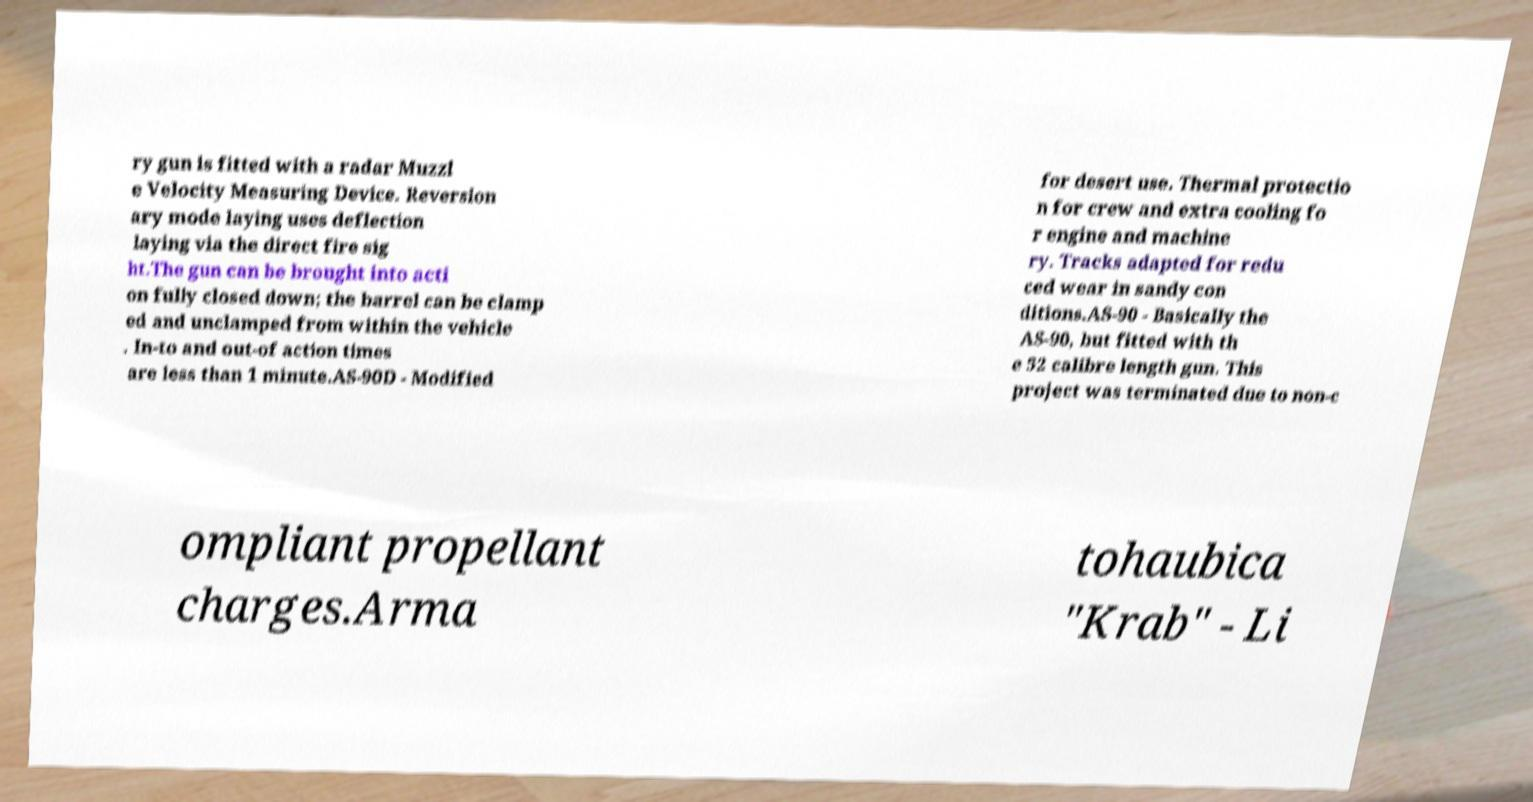Please read and relay the text visible in this image. What does it say? ry gun is fitted with a radar Muzzl e Velocity Measuring Device. Reversion ary mode laying uses deflection laying via the direct fire sig ht.The gun can be brought into acti on fully closed down; the barrel can be clamp ed and unclamped from within the vehicle . In-to and out-of action times are less than 1 minute.AS-90D - Modified for desert use. Thermal protectio n for crew and extra cooling fo r engine and machine ry. Tracks adapted for redu ced wear in sandy con ditions.AS-90 - Basically the AS-90, but fitted with th e 52 calibre length gun. This project was terminated due to non-c ompliant propellant charges.Arma tohaubica "Krab" - Li 